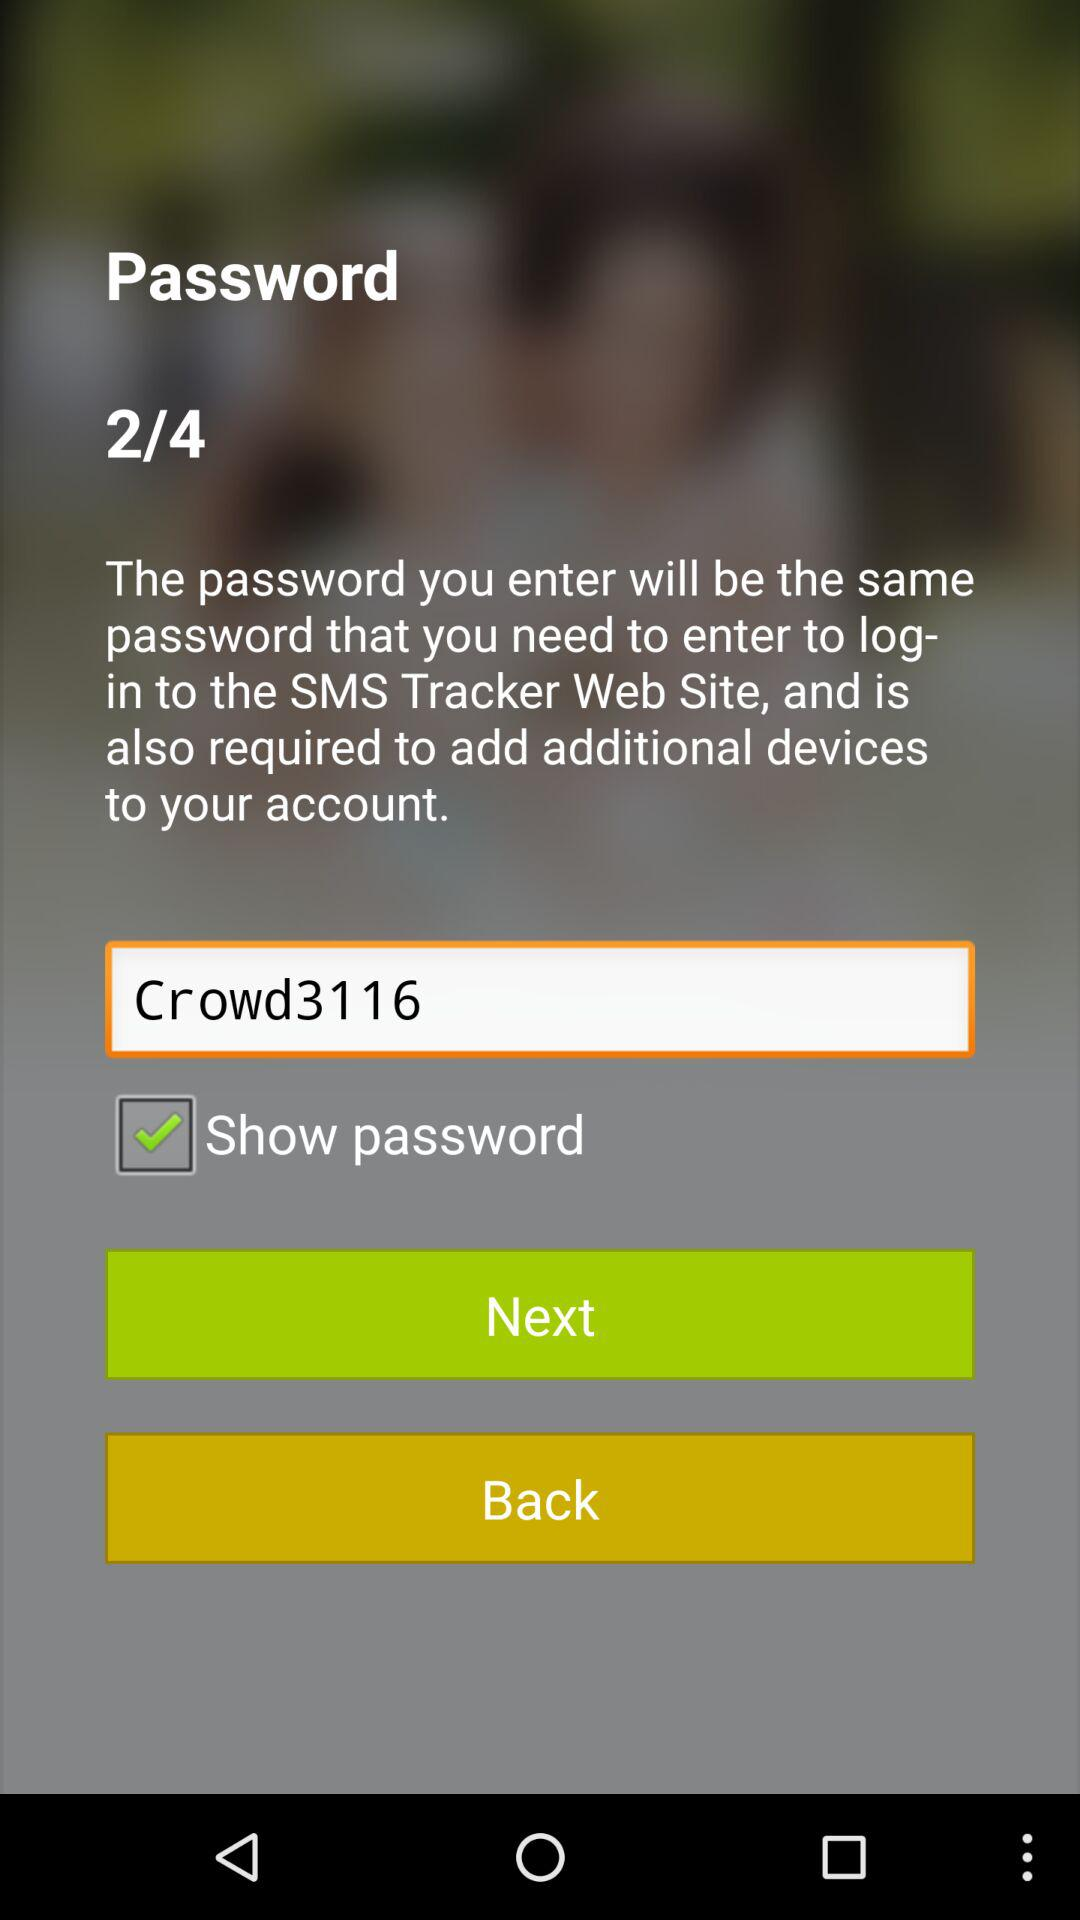Which page are we currently on? You are currently on the second page. 